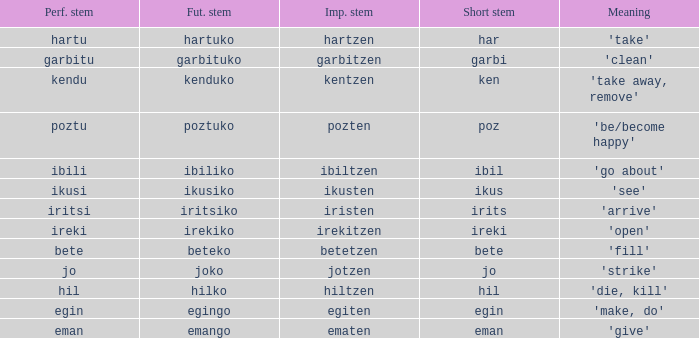Name the perfect stem for jo 1.0. 